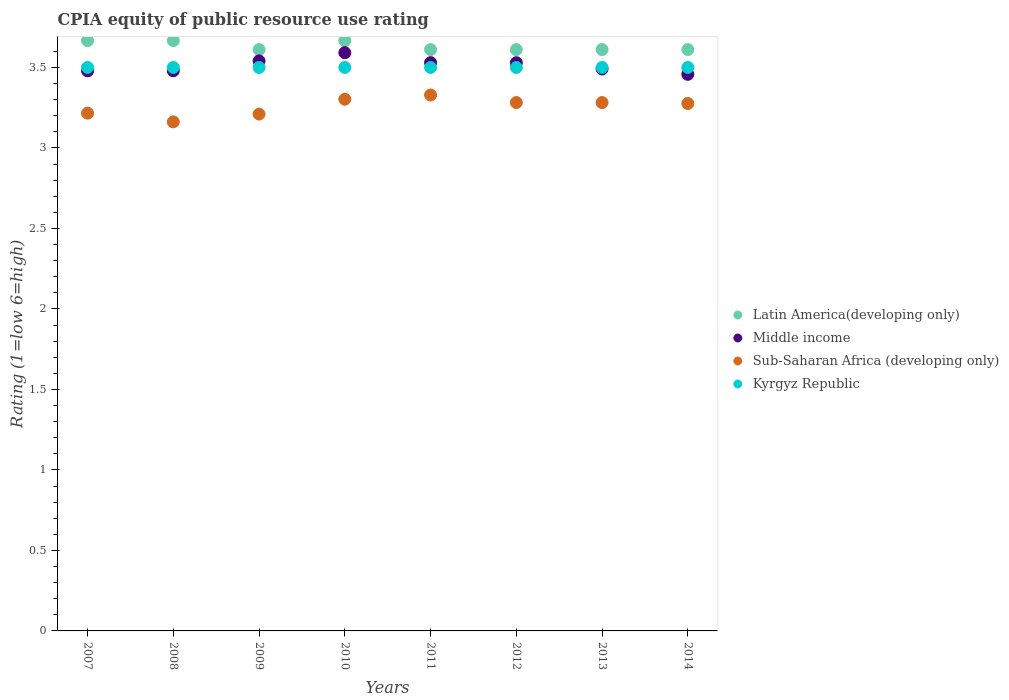What is the CPIA rating in Sub-Saharan Africa (developing only) in 2008?
Your answer should be very brief. 3.16. Across all years, what is the maximum CPIA rating in Middle income?
Give a very brief answer. 3.59. Across all years, what is the minimum CPIA rating in Kyrgyz Republic?
Your response must be concise. 3.5. What is the total CPIA rating in Kyrgyz Republic in the graph?
Ensure brevity in your answer.  28. What is the difference between the CPIA rating in Latin America(developing only) in 2013 and that in 2014?
Provide a succinct answer. 0. What is the difference between the CPIA rating in Latin America(developing only) in 2008 and the CPIA rating in Middle income in 2007?
Give a very brief answer. 0.19. What is the average CPIA rating in Kyrgyz Republic per year?
Your answer should be compact. 3.5. In the year 2009, what is the difference between the CPIA rating in Middle income and CPIA rating in Kyrgyz Republic?
Provide a succinct answer. 0.04. What is the ratio of the CPIA rating in Middle income in 2009 to that in 2012?
Give a very brief answer. 1. Is the CPIA rating in Latin America(developing only) in 2007 less than that in 2013?
Make the answer very short. No. Is the difference between the CPIA rating in Middle income in 2007 and 2008 greater than the difference between the CPIA rating in Kyrgyz Republic in 2007 and 2008?
Your response must be concise. No. What is the difference between the highest and the second highest CPIA rating in Sub-Saharan Africa (developing only)?
Offer a terse response. 0.03. Is the CPIA rating in Middle income strictly greater than the CPIA rating in Latin America(developing only) over the years?
Ensure brevity in your answer.  No. What is the difference between two consecutive major ticks on the Y-axis?
Offer a very short reply. 0.5. Does the graph contain any zero values?
Offer a very short reply. No. Does the graph contain grids?
Provide a short and direct response. No. How many legend labels are there?
Your answer should be compact. 4. How are the legend labels stacked?
Provide a succinct answer. Vertical. What is the title of the graph?
Your answer should be compact. CPIA equity of public resource use rating. What is the label or title of the X-axis?
Keep it short and to the point. Years. What is the Rating (1=low 6=high) in Latin America(developing only) in 2007?
Your answer should be compact. 3.67. What is the Rating (1=low 6=high) in Middle income in 2007?
Ensure brevity in your answer.  3.48. What is the Rating (1=low 6=high) in Sub-Saharan Africa (developing only) in 2007?
Offer a terse response. 3.22. What is the Rating (1=low 6=high) in Latin America(developing only) in 2008?
Provide a succinct answer. 3.67. What is the Rating (1=low 6=high) in Middle income in 2008?
Provide a short and direct response. 3.48. What is the Rating (1=low 6=high) of Sub-Saharan Africa (developing only) in 2008?
Provide a short and direct response. 3.16. What is the Rating (1=low 6=high) of Latin America(developing only) in 2009?
Provide a short and direct response. 3.61. What is the Rating (1=low 6=high) of Middle income in 2009?
Your answer should be compact. 3.54. What is the Rating (1=low 6=high) of Sub-Saharan Africa (developing only) in 2009?
Offer a terse response. 3.21. What is the Rating (1=low 6=high) of Latin America(developing only) in 2010?
Provide a short and direct response. 3.67. What is the Rating (1=low 6=high) in Middle income in 2010?
Make the answer very short. 3.59. What is the Rating (1=low 6=high) in Sub-Saharan Africa (developing only) in 2010?
Ensure brevity in your answer.  3.3. What is the Rating (1=low 6=high) in Kyrgyz Republic in 2010?
Your answer should be compact. 3.5. What is the Rating (1=low 6=high) in Latin America(developing only) in 2011?
Your answer should be very brief. 3.61. What is the Rating (1=low 6=high) of Middle income in 2011?
Your answer should be very brief. 3.53. What is the Rating (1=low 6=high) in Sub-Saharan Africa (developing only) in 2011?
Provide a succinct answer. 3.33. What is the Rating (1=low 6=high) in Latin America(developing only) in 2012?
Your answer should be compact. 3.61. What is the Rating (1=low 6=high) of Middle income in 2012?
Offer a terse response. 3.53. What is the Rating (1=low 6=high) of Sub-Saharan Africa (developing only) in 2012?
Make the answer very short. 3.28. What is the Rating (1=low 6=high) of Kyrgyz Republic in 2012?
Provide a short and direct response. 3.5. What is the Rating (1=low 6=high) of Latin America(developing only) in 2013?
Offer a very short reply. 3.61. What is the Rating (1=low 6=high) in Middle income in 2013?
Provide a succinct answer. 3.49. What is the Rating (1=low 6=high) of Sub-Saharan Africa (developing only) in 2013?
Ensure brevity in your answer.  3.28. What is the Rating (1=low 6=high) in Latin America(developing only) in 2014?
Ensure brevity in your answer.  3.61. What is the Rating (1=low 6=high) in Middle income in 2014?
Give a very brief answer. 3.46. What is the Rating (1=low 6=high) of Sub-Saharan Africa (developing only) in 2014?
Make the answer very short. 3.28. What is the Rating (1=low 6=high) in Kyrgyz Republic in 2014?
Offer a very short reply. 3.5. Across all years, what is the maximum Rating (1=low 6=high) in Latin America(developing only)?
Ensure brevity in your answer.  3.67. Across all years, what is the maximum Rating (1=low 6=high) of Middle income?
Keep it short and to the point. 3.59. Across all years, what is the maximum Rating (1=low 6=high) of Sub-Saharan Africa (developing only)?
Provide a short and direct response. 3.33. Across all years, what is the minimum Rating (1=low 6=high) in Latin America(developing only)?
Your response must be concise. 3.61. Across all years, what is the minimum Rating (1=low 6=high) of Middle income?
Give a very brief answer. 3.46. Across all years, what is the minimum Rating (1=low 6=high) in Sub-Saharan Africa (developing only)?
Keep it short and to the point. 3.16. Across all years, what is the minimum Rating (1=low 6=high) of Kyrgyz Republic?
Provide a succinct answer. 3.5. What is the total Rating (1=low 6=high) of Latin America(developing only) in the graph?
Keep it short and to the point. 29.06. What is the total Rating (1=low 6=high) of Middle income in the graph?
Offer a very short reply. 28.1. What is the total Rating (1=low 6=high) in Sub-Saharan Africa (developing only) in the graph?
Your response must be concise. 26.06. What is the total Rating (1=low 6=high) of Kyrgyz Republic in the graph?
Provide a succinct answer. 28. What is the difference between the Rating (1=low 6=high) of Sub-Saharan Africa (developing only) in 2007 and that in 2008?
Offer a very short reply. 0.05. What is the difference between the Rating (1=low 6=high) of Latin America(developing only) in 2007 and that in 2009?
Offer a very short reply. 0.06. What is the difference between the Rating (1=low 6=high) of Middle income in 2007 and that in 2009?
Make the answer very short. -0.06. What is the difference between the Rating (1=low 6=high) in Sub-Saharan Africa (developing only) in 2007 and that in 2009?
Offer a very short reply. 0.01. What is the difference between the Rating (1=low 6=high) in Kyrgyz Republic in 2007 and that in 2009?
Your answer should be very brief. 0. What is the difference between the Rating (1=low 6=high) of Latin America(developing only) in 2007 and that in 2010?
Your answer should be compact. 0. What is the difference between the Rating (1=low 6=high) in Middle income in 2007 and that in 2010?
Provide a short and direct response. -0.11. What is the difference between the Rating (1=low 6=high) in Sub-Saharan Africa (developing only) in 2007 and that in 2010?
Your answer should be very brief. -0.09. What is the difference between the Rating (1=low 6=high) in Kyrgyz Republic in 2007 and that in 2010?
Ensure brevity in your answer.  0. What is the difference between the Rating (1=low 6=high) in Latin America(developing only) in 2007 and that in 2011?
Make the answer very short. 0.06. What is the difference between the Rating (1=low 6=high) in Middle income in 2007 and that in 2011?
Your answer should be very brief. -0.05. What is the difference between the Rating (1=low 6=high) of Sub-Saharan Africa (developing only) in 2007 and that in 2011?
Your answer should be very brief. -0.11. What is the difference between the Rating (1=low 6=high) of Kyrgyz Republic in 2007 and that in 2011?
Provide a succinct answer. 0. What is the difference between the Rating (1=low 6=high) in Latin America(developing only) in 2007 and that in 2012?
Offer a terse response. 0.06. What is the difference between the Rating (1=low 6=high) in Middle income in 2007 and that in 2012?
Provide a succinct answer. -0.05. What is the difference between the Rating (1=low 6=high) in Sub-Saharan Africa (developing only) in 2007 and that in 2012?
Offer a terse response. -0.07. What is the difference between the Rating (1=low 6=high) in Kyrgyz Republic in 2007 and that in 2012?
Offer a very short reply. 0. What is the difference between the Rating (1=low 6=high) of Latin America(developing only) in 2007 and that in 2013?
Your answer should be compact. 0.06. What is the difference between the Rating (1=low 6=high) in Middle income in 2007 and that in 2013?
Your answer should be very brief. -0.01. What is the difference between the Rating (1=low 6=high) in Sub-Saharan Africa (developing only) in 2007 and that in 2013?
Your response must be concise. -0.07. What is the difference between the Rating (1=low 6=high) in Latin America(developing only) in 2007 and that in 2014?
Provide a short and direct response. 0.06. What is the difference between the Rating (1=low 6=high) of Middle income in 2007 and that in 2014?
Ensure brevity in your answer.  0.02. What is the difference between the Rating (1=low 6=high) in Sub-Saharan Africa (developing only) in 2007 and that in 2014?
Your answer should be compact. -0.06. What is the difference between the Rating (1=low 6=high) of Latin America(developing only) in 2008 and that in 2009?
Your answer should be compact. 0.06. What is the difference between the Rating (1=low 6=high) in Middle income in 2008 and that in 2009?
Keep it short and to the point. -0.06. What is the difference between the Rating (1=low 6=high) in Sub-Saharan Africa (developing only) in 2008 and that in 2009?
Your answer should be very brief. -0.05. What is the difference between the Rating (1=low 6=high) in Latin America(developing only) in 2008 and that in 2010?
Your response must be concise. 0. What is the difference between the Rating (1=low 6=high) in Middle income in 2008 and that in 2010?
Keep it short and to the point. -0.11. What is the difference between the Rating (1=low 6=high) of Sub-Saharan Africa (developing only) in 2008 and that in 2010?
Make the answer very short. -0.14. What is the difference between the Rating (1=low 6=high) in Kyrgyz Republic in 2008 and that in 2010?
Keep it short and to the point. 0. What is the difference between the Rating (1=low 6=high) in Latin America(developing only) in 2008 and that in 2011?
Your answer should be very brief. 0.06. What is the difference between the Rating (1=low 6=high) of Middle income in 2008 and that in 2011?
Provide a succinct answer. -0.05. What is the difference between the Rating (1=low 6=high) in Sub-Saharan Africa (developing only) in 2008 and that in 2011?
Provide a short and direct response. -0.17. What is the difference between the Rating (1=low 6=high) of Kyrgyz Republic in 2008 and that in 2011?
Your answer should be very brief. 0. What is the difference between the Rating (1=low 6=high) of Latin America(developing only) in 2008 and that in 2012?
Your answer should be very brief. 0.06. What is the difference between the Rating (1=low 6=high) in Middle income in 2008 and that in 2012?
Provide a succinct answer. -0.05. What is the difference between the Rating (1=low 6=high) in Sub-Saharan Africa (developing only) in 2008 and that in 2012?
Offer a very short reply. -0.12. What is the difference between the Rating (1=low 6=high) of Latin America(developing only) in 2008 and that in 2013?
Ensure brevity in your answer.  0.06. What is the difference between the Rating (1=low 6=high) in Middle income in 2008 and that in 2013?
Your response must be concise. -0.01. What is the difference between the Rating (1=low 6=high) in Sub-Saharan Africa (developing only) in 2008 and that in 2013?
Your response must be concise. -0.12. What is the difference between the Rating (1=low 6=high) in Kyrgyz Republic in 2008 and that in 2013?
Offer a terse response. 0. What is the difference between the Rating (1=low 6=high) of Latin America(developing only) in 2008 and that in 2014?
Your answer should be very brief. 0.06. What is the difference between the Rating (1=low 6=high) of Middle income in 2008 and that in 2014?
Offer a terse response. 0.02. What is the difference between the Rating (1=low 6=high) in Sub-Saharan Africa (developing only) in 2008 and that in 2014?
Provide a succinct answer. -0.11. What is the difference between the Rating (1=low 6=high) of Latin America(developing only) in 2009 and that in 2010?
Your response must be concise. -0.06. What is the difference between the Rating (1=low 6=high) in Middle income in 2009 and that in 2010?
Keep it short and to the point. -0.05. What is the difference between the Rating (1=low 6=high) of Sub-Saharan Africa (developing only) in 2009 and that in 2010?
Your answer should be very brief. -0.09. What is the difference between the Rating (1=low 6=high) of Kyrgyz Republic in 2009 and that in 2010?
Your answer should be compact. 0. What is the difference between the Rating (1=low 6=high) in Middle income in 2009 and that in 2011?
Your answer should be compact. 0.01. What is the difference between the Rating (1=low 6=high) of Sub-Saharan Africa (developing only) in 2009 and that in 2011?
Make the answer very short. -0.12. What is the difference between the Rating (1=low 6=high) of Latin America(developing only) in 2009 and that in 2012?
Provide a succinct answer. 0. What is the difference between the Rating (1=low 6=high) of Middle income in 2009 and that in 2012?
Your response must be concise. 0.01. What is the difference between the Rating (1=low 6=high) in Sub-Saharan Africa (developing only) in 2009 and that in 2012?
Your response must be concise. -0.07. What is the difference between the Rating (1=low 6=high) of Kyrgyz Republic in 2009 and that in 2012?
Make the answer very short. 0. What is the difference between the Rating (1=low 6=high) in Latin America(developing only) in 2009 and that in 2013?
Ensure brevity in your answer.  0. What is the difference between the Rating (1=low 6=high) of Middle income in 2009 and that in 2013?
Provide a short and direct response. 0.05. What is the difference between the Rating (1=low 6=high) in Sub-Saharan Africa (developing only) in 2009 and that in 2013?
Offer a very short reply. -0.07. What is the difference between the Rating (1=low 6=high) of Kyrgyz Republic in 2009 and that in 2013?
Keep it short and to the point. 0. What is the difference between the Rating (1=low 6=high) in Middle income in 2009 and that in 2014?
Provide a short and direct response. 0.08. What is the difference between the Rating (1=low 6=high) of Sub-Saharan Africa (developing only) in 2009 and that in 2014?
Provide a short and direct response. -0.07. What is the difference between the Rating (1=low 6=high) in Kyrgyz Republic in 2009 and that in 2014?
Offer a terse response. 0. What is the difference between the Rating (1=low 6=high) of Latin America(developing only) in 2010 and that in 2011?
Your answer should be compact. 0.06. What is the difference between the Rating (1=low 6=high) of Middle income in 2010 and that in 2011?
Your answer should be very brief. 0.06. What is the difference between the Rating (1=low 6=high) in Sub-Saharan Africa (developing only) in 2010 and that in 2011?
Provide a short and direct response. -0.03. What is the difference between the Rating (1=low 6=high) in Latin America(developing only) in 2010 and that in 2012?
Your answer should be compact. 0.06. What is the difference between the Rating (1=low 6=high) in Middle income in 2010 and that in 2012?
Provide a succinct answer. 0.06. What is the difference between the Rating (1=low 6=high) in Sub-Saharan Africa (developing only) in 2010 and that in 2012?
Your answer should be very brief. 0.02. What is the difference between the Rating (1=low 6=high) in Latin America(developing only) in 2010 and that in 2013?
Offer a very short reply. 0.06. What is the difference between the Rating (1=low 6=high) in Middle income in 2010 and that in 2013?
Make the answer very short. 0.1. What is the difference between the Rating (1=low 6=high) in Sub-Saharan Africa (developing only) in 2010 and that in 2013?
Give a very brief answer. 0.02. What is the difference between the Rating (1=low 6=high) of Latin America(developing only) in 2010 and that in 2014?
Give a very brief answer. 0.06. What is the difference between the Rating (1=low 6=high) of Middle income in 2010 and that in 2014?
Offer a terse response. 0.13. What is the difference between the Rating (1=low 6=high) of Sub-Saharan Africa (developing only) in 2010 and that in 2014?
Offer a very short reply. 0.03. What is the difference between the Rating (1=low 6=high) of Latin America(developing only) in 2011 and that in 2012?
Provide a short and direct response. 0. What is the difference between the Rating (1=low 6=high) in Middle income in 2011 and that in 2012?
Your answer should be very brief. 0. What is the difference between the Rating (1=low 6=high) of Sub-Saharan Africa (developing only) in 2011 and that in 2012?
Offer a very short reply. 0.05. What is the difference between the Rating (1=low 6=high) in Kyrgyz Republic in 2011 and that in 2012?
Provide a succinct answer. 0. What is the difference between the Rating (1=low 6=high) of Latin America(developing only) in 2011 and that in 2013?
Make the answer very short. 0. What is the difference between the Rating (1=low 6=high) of Middle income in 2011 and that in 2013?
Offer a terse response. 0.04. What is the difference between the Rating (1=low 6=high) in Sub-Saharan Africa (developing only) in 2011 and that in 2013?
Your answer should be compact. 0.05. What is the difference between the Rating (1=low 6=high) of Middle income in 2011 and that in 2014?
Keep it short and to the point. 0.07. What is the difference between the Rating (1=low 6=high) of Sub-Saharan Africa (developing only) in 2011 and that in 2014?
Your answer should be very brief. 0.05. What is the difference between the Rating (1=low 6=high) of Kyrgyz Republic in 2011 and that in 2014?
Provide a short and direct response. 0. What is the difference between the Rating (1=low 6=high) of Middle income in 2012 and that in 2013?
Keep it short and to the point. 0.04. What is the difference between the Rating (1=low 6=high) of Sub-Saharan Africa (developing only) in 2012 and that in 2013?
Offer a terse response. 0. What is the difference between the Rating (1=low 6=high) of Kyrgyz Republic in 2012 and that in 2013?
Your response must be concise. 0. What is the difference between the Rating (1=low 6=high) of Middle income in 2012 and that in 2014?
Your answer should be very brief. 0.07. What is the difference between the Rating (1=low 6=high) in Sub-Saharan Africa (developing only) in 2012 and that in 2014?
Keep it short and to the point. 0.01. What is the difference between the Rating (1=low 6=high) in Latin America(developing only) in 2013 and that in 2014?
Your answer should be compact. 0. What is the difference between the Rating (1=low 6=high) in Middle income in 2013 and that in 2014?
Provide a succinct answer. 0.03. What is the difference between the Rating (1=low 6=high) of Sub-Saharan Africa (developing only) in 2013 and that in 2014?
Your answer should be very brief. 0.01. What is the difference between the Rating (1=low 6=high) in Kyrgyz Republic in 2013 and that in 2014?
Provide a short and direct response. 0. What is the difference between the Rating (1=low 6=high) in Latin America(developing only) in 2007 and the Rating (1=low 6=high) in Middle income in 2008?
Ensure brevity in your answer.  0.19. What is the difference between the Rating (1=low 6=high) in Latin America(developing only) in 2007 and the Rating (1=low 6=high) in Sub-Saharan Africa (developing only) in 2008?
Your answer should be compact. 0.5. What is the difference between the Rating (1=low 6=high) of Latin America(developing only) in 2007 and the Rating (1=low 6=high) of Kyrgyz Republic in 2008?
Your answer should be compact. 0.17. What is the difference between the Rating (1=low 6=high) in Middle income in 2007 and the Rating (1=low 6=high) in Sub-Saharan Africa (developing only) in 2008?
Your answer should be compact. 0.32. What is the difference between the Rating (1=low 6=high) of Middle income in 2007 and the Rating (1=low 6=high) of Kyrgyz Republic in 2008?
Offer a very short reply. -0.02. What is the difference between the Rating (1=low 6=high) of Sub-Saharan Africa (developing only) in 2007 and the Rating (1=low 6=high) of Kyrgyz Republic in 2008?
Give a very brief answer. -0.28. What is the difference between the Rating (1=low 6=high) of Latin America(developing only) in 2007 and the Rating (1=low 6=high) of Middle income in 2009?
Keep it short and to the point. 0.13. What is the difference between the Rating (1=low 6=high) in Latin America(developing only) in 2007 and the Rating (1=low 6=high) in Sub-Saharan Africa (developing only) in 2009?
Give a very brief answer. 0.46. What is the difference between the Rating (1=low 6=high) in Middle income in 2007 and the Rating (1=low 6=high) in Sub-Saharan Africa (developing only) in 2009?
Your response must be concise. 0.27. What is the difference between the Rating (1=low 6=high) in Middle income in 2007 and the Rating (1=low 6=high) in Kyrgyz Republic in 2009?
Make the answer very short. -0.02. What is the difference between the Rating (1=low 6=high) in Sub-Saharan Africa (developing only) in 2007 and the Rating (1=low 6=high) in Kyrgyz Republic in 2009?
Provide a short and direct response. -0.28. What is the difference between the Rating (1=low 6=high) of Latin America(developing only) in 2007 and the Rating (1=low 6=high) of Middle income in 2010?
Make the answer very short. 0.07. What is the difference between the Rating (1=low 6=high) of Latin America(developing only) in 2007 and the Rating (1=low 6=high) of Sub-Saharan Africa (developing only) in 2010?
Your response must be concise. 0.36. What is the difference between the Rating (1=low 6=high) in Middle income in 2007 and the Rating (1=low 6=high) in Sub-Saharan Africa (developing only) in 2010?
Provide a succinct answer. 0.18. What is the difference between the Rating (1=low 6=high) of Middle income in 2007 and the Rating (1=low 6=high) of Kyrgyz Republic in 2010?
Give a very brief answer. -0.02. What is the difference between the Rating (1=low 6=high) of Sub-Saharan Africa (developing only) in 2007 and the Rating (1=low 6=high) of Kyrgyz Republic in 2010?
Keep it short and to the point. -0.28. What is the difference between the Rating (1=low 6=high) of Latin America(developing only) in 2007 and the Rating (1=low 6=high) of Middle income in 2011?
Ensure brevity in your answer.  0.14. What is the difference between the Rating (1=low 6=high) of Latin America(developing only) in 2007 and the Rating (1=low 6=high) of Sub-Saharan Africa (developing only) in 2011?
Offer a terse response. 0.34. What is the difference between the Rating (1=low 6=high) of Middle income in 2007 and the Rating (1=low 6=high) of Sub-Saharan Africa (developing only) in 2011?
Ensure brevity in your answer.  0.15. What is the difference between the Rating (1=low 6=high) of Middle income in 2007 and the Rating (1=low 6=high) of Kyrgyz Republic in 2011?
Your answer should be very brief. -0.02. What is the difference between the Rating (1=low 6=high) in Sub-Saharan Africa (developing only) in 2007 and the Rating (1=low 6=high) in Kyrgyz Republic in 2011?
Your answer should be very brief. -0.28. What is the difference between the Rating (1=low 6=high) of Latin America(developing only) in 2007 and the Rating (1=low 6=high) of Middle income in 2012?
Give a very brief answer. 0.14. What is the difference between the Rating (1=low 6=high) of Latin America(developing only) in 2007 and the Rating (1=low 6=high) of Sub-Saharan Africa (developing only) in 2012?
Your answer should be compact. 0.38. What is the difference between the Rating (1=low 6=high) in Middle income in 2007 and the Rating (1=low 6=high) in Sub-Saharan Africa (developing only) in 2012?
Give a very brief answer. 0.2. What is the difference between the Rating (1=low 6=high) in Middle income in 2007 and the Rating (1=low 6=high) in Kyrgyz Republic in 2012?
Provide a succinct answer. -0.02. What is the difference between the Rating (1=low 6=high) of Sub-Saharan Africa (developing only) in 2007 and the Rating (1=low 6=high) of Kyrgyz Republic in 2012?
Offer a very short reply. -0.28. What is the difference between the Rating (1=low 6=high) in Latin America(developing only) in 2007 and the Rating (1=low 6=high) in Middle income in 2013?
Ensure brevity in your answer.  0.18. What is the difference between the Rating (1=low 6=high) in Latin America(developing only) in 2007 and the Rating (1=low 6=high) in Sub-Saharan Africa (developing only) in 2013?
Offer a very short reply. 0.38. What is the difference between the Rating (1=low 6=high) in Latin America(developing only) in 2007 and the Rating (1=low 6=high) in Kyrgyz Republic in 2013?
Make the answer very short. 0.17. What is the difference between the Rating (1=low 6=high) of Middle income in 2007 and the Rating (1=low 6=high) of Sub-Saharan Africa (developing only) in 2013?
Give a very brief answer. 0.2. What is the difference between the Rating (1=low 6=high) of Middle income in 2007 and the Rating (1=low 6=high) of Kyrgyz Republic in 2013?
Your answer should be compact. -0.02. What is the difference between the Rating (1=low 6=high) of Sub-Saharan Africa (developing only) in 2007 and the Rating (1=low 6=high) of Kyrgyz Republic in 2013?
Give a very brief answer. -0.28. What is the difference between the Rating (1=low 6=high) of Latin America(developing only) in 2007 and the Rating (1=low 6=high) of Middle income in 2014?
Your response must be concise. 0.21. What is the difference between the Rating (1=low 6=high) of Latin America(developing only) in 2007 and the Rating (1=low 6=high) of Sub-Saharan Africa (developing only) in 2014?
Make the answer very short. 0.39. What is the difference between the Rating (1=low 6=high) in Latin America(developing only) in 2007 and the Rating (1=low 6=high) in Kyrgyz Republic in 2014?
Offer a very short reply. 0.17. What is the difference between the Rating (1=low 6=high) of Middle income in 2007 and the Rating (1=low 6=high) of Sub-Saharan Africa (developing only) in 2014?
Offer a terse response. 0.2. What is the difference between the Rating (1=low 6=high) in Middle income in 2007 and the Rating (1=low 6=high) in Kyrgyz Republic in 2014?
Provide a succinct answer. -0.02. What is the difference between the Rating (1=low 6=high) in Sub-Saharan Africa (developing only) in 2007 and the Rating (1=low 6=high) in Kyrgyz Republic in 2014?
Your response must be concise. -0.28. What is the difference between the Rating (1=low 6=high) in Latin America(developing only) in 2008 and the Rating (1=low 6=high) in Middle income in 2009?
Ensure brevity in your answer.  0.13. What is the difference between the Rating (1=low 6=high) in Latin America(developing only) in 2008 and the Rating (1=low 6=high) in Sub-Saharan Africa (developing only) in 2009?
Ensure brevity in your answer.  0.46. What is the difference between the Rating (1=low 6=high) in Latin America(developing only) in 2008 and the Rating (1=low 6=high) in Kyrgyz Republic in 2009?
Make the answer very short. 0.17. What is the difference between the Rating (1=low 6=high) of Middle income in 2008 and the Rating (1=low 6=high) of Sub-Saharan Africa (developing only) in 2009?
Ensure brevity in your answer.  0.27. What is the difference between the Rating (1=low 6=high) in Middle income in 2008 and the Rating (1=low 6=high) in Kyrgyz Republic in 2009?
Your answer should be very brief. -0.02. What is the difference between the Rating (1=low 6=high) of Sub-Saharan Africa (developing only) in 2008 and the Rating (1=low 6=high) of Kyrgyz Republic in 2009?
Your answer should be very brief. -0.34. What is the difference between the Rating (1=low 6=high) in Latin America(developing only) in 2008 and the Rating (1=low 6=high) in Middle income in 2010?
Provide a succinct answer. 0.07. What is the difference between the Rating (1=low 6=high) of Latin America(developing only) in 2008 and the Rating (1=low 6=high) of Sub-Saharan Africa (developing only) in 2010?
Ensure brevity in your answer.  0.36. What is the difference between the Rating (1=low 6=high) in Middle income in 2008 and the Rating (1=low 6=high) in Sub-Saharan Africa (developing only) in 2010?
Give a very brief answer. 0.18. What is the difference between the Rating (1=low 6=high) in Middle income in 2008 and the Rating (1=low 6=high) in Kyrgyz Republic in 2010?
Provide a short and direct response. -0.02. What is the difference between the Rating (1=low 6=high) of Sub-Saharan Africa (developing only) in 2008 and the Rating (1=low 6=high) of Kyrgyz Republic in 2010?
Give a very brief answer. -0.34. What is the difference between the Rating (1=low 6=high) of Latin America(developing only) in 2008 and the Rating (1=low 6=high) of Middle income in 2011?
Your answer should be very brief. 0.14. What is the difference between the Rating (1=low 6=high) of Latin America(developing only) in 2008 and the Rating (1=low 6=high) of Sub-Saharan Africa (developing only) in 2011?
Provide a short and direct response. 0.34. What is the difference between the Rating (1=low 6=high) in Middle income in 2008 and the Rating (1=low 6=high) in Sub-Saharan Africa (developing only) in 2011?
Your answer should be compact. 0.15. What is the difference between the Rating (1=low 6=high) in Middle income in 2008 and the Rating (1=low 6=high) in Kyrgyz Republic in 2011?
Your answer should be very brief. -0.02. What is the difference between the Rating (1=low 6=high) of Sub-Saharan Africa (developing only) in 2008 and the Rating (1=low 6=high) of Kyrgyz Republic in 2011?
Keep it short and to the point. -0.34. What is the difference between the Rating (1=low 6=high) in Latin America(developing only) in 2008 and the Rating (1=low 6=high) in Middle income in 2012?
Offer a very short reply. 0.14. What is the difference between the Rating (1=low 6=high) in Latin America(developing only) in 2008 and the Rating (1=low 6=high) in Sub-Saharan Africa (developing only) in 2012?
Your response must be concise. 0.38. What is the difference between the Rating (1=low 6=high) in Middle income in 2008 and the Rating (1=low 6=high) in Sub-Saharan Africa (developing only) in 2012?
Your answer should be compact. 0.2. What is the difference between the Rating (1=low 6=high) in Middle income in 2008 and the Rating (1=low 6=high) in Kyrgyz Republic in 2012?
Give a very brief answer. -0.02. What is the difference between the Rating (1=low 6=high) of Sub-Saharan Africa (developing only) in 2008 and the Rating (1=low 6=high) of Kyrgyz Republic in 2012?
Provide a succinct answer. -0.34. What is the difference between the Rating (1=low 6=high) in Latin America(developing only) in 2008 and the Rating (1=low 6=high) in Middle income in 2013?
Offer a very short reply. 0.18. What is the difference between the Rating (1=low 6=high) of Latin America(developing only) in 2008 and the Rating (1=low 6=high) of Sub-Saharan Africa (developing only) in 2013?
Your answer should be compact. 0.38. What is the difference between the Rating (1=low 6=high) in Middle income in 2008 and the Rating (1=low 6=high) in Sub-Saharan Africa (developing only) in 2013?
Your response must be concise. 0.2. What is the difference between the Rating (1=low 6=high) of Middle income in 2008 and the Rating (1=low 6=high) of Kyrgyz Republic in 2013?
Your response must be concise. -0.02. What is the difference between the Rating (1=low 6=high) of Sub-Saharan Africa (developing only) in 2008 and the Rating (1=low 6=high) of Kyrgyz Republic in 2013?
Provide a succinct answer. -0.34. What is the difference between the Rating (1=low 6=high) of Latin America(developing only) in 2008 and the Rating (1=low 6=high) of Middle income in 2014?
Provide a short and direct response. 0.21. What is the difference between the Rating (1=low 6=high) of Latin America(developing only) in 2008 and the Rating (1=low 6=high) of Sub-Saharan Africa (developing only) in 2014?
Your response must be concise. 0.39. What is the difference between the Rating (1=low 6=high) in Latin America(developing only) in 2008 and the Rating (1=low 6=high) in Kyrgyz Republic in 2014?
Provide a succinct answer. 0.17. What is the difference between the Rating (1=low 6=high) in Middle income in 2008 and the Rating (1=low 6=high) in Sub-Saharan Africa (developing only) in 2014?
Make the answer very short. 0.2. What is the difference between the Rating (1=low 6=high) in Middle income in 2008 and the Rating (1=low 6=high) in Kyrgyz Republic in 2014?
Ensure brevity in your answer.  -0.02. What is the difference between the Rating (1=low 6=high) of Sub-Saharan Africa (developing only) in 2008 and the Rating (1=low 6=high) of Kyrgyz Republic in 2014?
Give a very brief answer. -0.34. What is the difference between the Rating (1=low 6=high) of Latin America(developing only) in 2009 and the Rating (1=low 6=high) of Middle income in 2010?
Provide a short and direct response. 0.02. What is the difference between the Rating (1=low 6=high) in Latin America(developing only) in 2009 and the Rating (1=low 6=high) in Sub-Saharan Africa (developing only) in 2010?
Ensure brevity in your answer.  0.31. What is the difference between the Rating (1=low 6=high) in Latin America(developing only) in 2009 and the Rating (1=low 6=high) in Kyrgyz Republic in 2010?
Offer a very short reply. 0.11. What is the difference between the Rating (1=low 6=high) in Middle income in 2009 and the Rating (1=low 6=high) in Sub-Saharan Africa (developing only) in 2010?
Offer a terse response. 0.24. What is the difference between the Rating (1=low 6=high) in Middle income in 2009 and the Rating (1=low 6=high) in Kyrgyz Republic in 2010?
Your response must be concise. 0.04. What is the difference between the Rating (1=low 6=high) in Sub-Saharan Africa (developing only) in 2009 and the Rating (1=low 6=high) in Kyrgyz Republic in 2010?
Your response must be concise. -0.29. What is the difference between the Rating (1=low 6=high) of Latin America(developing only) in 2009 and the Rating (1=low 6=high) of Middle income in 2011?
Provide a succinct answer. 0.08. What is the difference between the Rating (1=low 6=high) in Latin America(developing only) in 2009 and the Rating (1=low 6=high) in Sub-Saharan Africa (developing only) in 2011?
Offer a terse response. 0.28. What is the difference between the Rating (1=low 6=high) in Latin America(developing only) in 2009 and the Rating (1=low 6=high) in Kyrgyz Republic in 2011?
Make the answer very short. 0.11. What is the difference between the Rating (1=low 6=high) in Middle income in 2009 and the Rating (1=low 6=high) in Sub-Saharan Africa (developing only) in 2011?
Your answer should be very brief. 0.21. What is the difference between the Rating (1=low 6=high) in Middle income in 2009 and the Rating (1=low 6=high) in Kyrgyz Republic in 2011?
Offer a terse response. 0.04. What is the difference between the Rating (1=low 6=high) in Sub-Saharan Africa (developing only) in 2009 and the Rating (1=low 6=high) in Kyrgyz Republic in 2011?
Keep it short and to the point. -0.29. What is the difference between the Rating (1=low 6=high) of Latin America(developing only) in 2009 and the Rating (1=low 6=high) of Middle income in 2012?
Provide a short and direct response. 0.08. What is the difference between the Rating (1=low 6=high) in Latin America(developing only) in 2009 and the Rating (1=low 6=high) in Sub-Saharan Africa (developing only) in 2012?
Your response must be concise. 0.33. What is the difference between the Rating (1=low 6=high) in Middle income in 2009 and the Rating (1=low 6=high) in Sub-Saharan Africa (developing only) in 2012?
Offer a terse response. 0.26. What is the difference between the Rating (1=low 6=high) of Middle income in 2009 and the Rating (1=low 6=high) of Kyrgyz Republic in 2012?
Provide a short and direct response. 0.04. What is the difference between the Rating (1=low 6=high) of Sub-Saharan Africa (developing only) in 2009 and the Rating (1=low 6=high) of Kyrgyz Republic in 2012?
Your answer should be very brief. -0.29. What is the difference between the Rating (1=low 6=high) in Latin America(developing only) in 2009 and the Rating (1=low 6=high) in Middle income in 2013?
Your response must be concise. 0.12. What is the difference between the Rating (1=low 6=high) in Latin America(developing only) in 2009 and the Rating (1=low 6=high) in Sub-Saharan Africa (developing only) in 2013?
Offer a terse response. 0.33. What is the difference between the Rating (1=low 6=high) in Middle income in 2009 and the Rating (1=low 6=high) in Sub-Saharan Africa (developing only) in 2013?
Keep it short and to the point. 0.26. What is the difference between the Rating (1=low 6=high) in Middle income in 2009 and the Rating (1=low 6=high) in Kyrgyz Republic in 2013?
Provide a short and direct response. 0.04. What is the difference between the Rating (1=low 6=high) of Sub-Saharan Africa (developing only) in 2009 and the Rating (1=low 6=high) of Kyrgyz Republic in 2013?
Offer a very short reply. -0.29. What is the difference between the Rating (1=low 6=high) of Latin America(developing only) in 2009 and the Rating (1=low 6=high) of Middle income in 2014?
Offer a very short reply. 0.15. What is the difference between the Rating (1=low 6=high) in Latin America(developing only) in 2009 and the Rating (1=low 6=high) in Sub-Saharan Africa (developing only) in 2014?
Your answer should be very brief. 0.33. What is the difference between the Rating (1=low 6=high) of Middle income in 2009 and the Rating (1=low 6=high) of Sub-Saharan Africa (developing only) in 2014?
Provide a succinct answer. 0.26. What is the difference between the Rating (1=low 6=high) of Middle income in 2009 and the Rating (1=low 6=high) of Kyrgyz Republic in 2014?
Provide a short and direct response. 0.04. What is the difference between the Rating (1=low 6=high) of Sub-Saharan Africa (developing only) in 2009 and the Rating (1=low 6=high) of Kyrgyz Republic in 2014?
Ensure brevity in your answer.  -0.29. What is the difference between the Rating (1=low 6=high) of Latin America(developing only) in 2010 and the Rating (1=low 6=high) of Middle income in 2011?
Offer a terse response. 0.14. What is the difference between the Rating (1=low 6=high) in Latin America(developing only) in 2010 and the Rating (1=low 6=high) in Sub-Saharan Africa (developing only) in 2011?
Provide a succinct answer. 0.34. What is the difference between the Rating (1=low 6=high) in Latin America(developing only) in 2010 and the Rating (1=low 6=high) in Kyrgyz Republic in 2011?
Keep it short and to the point. 0.17. What is the difference between the Rating (1=low 6=high) in Middle income in 2010 and the Rating (1=low 6=high) in Sub-Saharan Africa (developing only) in 2011?
Your answer should be very brief. 0.26. What is the difference between the Rating (1=low 6=high) of Middle income in 2010 and the Rating (1=low 6=high) of Kyrgyz Republic in 2011?
Your response must be concise. 0.09. What is the difference between the Rating (1=low 6=high) in Sub-Saharan Africa (developing only) in 2010 and the Rating (1=low 6=high) in Kyrgyz Republic in 2011?
Provide a short and direct response. -0.2. What is the difference between the Rating (1=low 6=high) of Latin America(developing only) in 2010 and the Rating (1=low 6=high) of Middle income in 2012?
Give a very brief answer. 0.14. What is the difference between the Rating (1=low 6=high) of Latin America(developing only) in 2010 and the Rating (1=low 6=high) of Sub-Saharan Africa (developing only) in 2012?
Offer a very short reply. 0.38. What is the difference between the Rating (1=low 6=high) in Latin America(developing only) in 2010 and the Rating (1=low 6=high) in Kyrgyz Republic in 2012?
Your response must be concise. 0.17. What is the difference between the Rating (1=low 6=high) in Middle income in 2010 and the Rating (1=low 6=high) in Sub-Saharan Africa (developing only) in 2012?
Give a very brief answer. 0.31. What is the difference between the Rating (1=low 6=high) in Middle income in 2010 and the Rating (1=low 6=high) in Kyrgyz Republic in 2012?
Offer a very short reply. 0.09. What is the difference between the Rating (1=low 6=high) of Sub-Saharan Africa (developing only) in 2010 and the Rating (1=low 6=high) of Kyrgyz Republic in 2012?
Your response must be concise. -0.2. What is the difference between the Rating (1=low 6=high) in Latin America(developing only) in 2010 and the Rating (1=low 6=high) in Middle income in 2013?
Provide a succinct answer. 0.18. What is the difference between the Rating (1=low 6=high) in Latin America(developing only) in 2010 and the Rating (1=low 6=high) in Sub-Saharan Africa (developing only) in 2013?
Ensure brevity in your answer.  0.38. What is the difference between the Rating (1=low 6=high) of Middle income in 2010 and the Rating (1=low 6=high) of Sub-Saharan Africa (developing only) in 2013?
Offer a very short reply. 0.31. What is the difference between the Rating (1=low 6=high) of Middle income in 2010 and the Rating (1=low 6=high) of Kyrgyz Republic in 2013?
Ensure brevity in your answer.  0.09. What is the difference between the Rating (1=low 6=high) in Sub-Saharan Africa (developing only) in 2010 and the Rating (1=low 6=high) in Kyrgyz Republic in 2013?
Provide a succinct answer. -0.2. What is the difference between the Rating (1=low 6=high) of Latin America(developing only) in 2010 and the Rating (1=low 6=high) of Middle income in 2014?
Give a very brief answer. 0.21. What is the difference between the Rating (1=low 6=high) in Latin America(developing only) in 2010 and the Rating (1=low 6=high) in Sub-Saharan Africa (developing only) in 2014?
Give a very brief answer. 0.39. What is the difference between the Rating (1=low 6=high) in Latin America(developing only) in 2010 and the Rating (1=low 6=high) in Kyrgyz Republic in 2014?
Your response must be concise. 0.17. What is the difference between the Rating (1=low 6=high) in Middle income in 2010 and the Rating (1=low 6=high) in Sub-Saharan Africa (developing only) in 2014?
Make the answer very short. 0.32. What is the difference between the Rating (1=low 6=high) of Middle income in 2010 and the Rating (1=low 6=high) of Kyrgyz Republic in 2014?
Your response must be concise. 0.09. What is the difference between the Rating (1=low 6=high) in Sub-Saharan Africa (developing only) in 2010 and the Rating (1=low 6=high) in Kyrgyz Republic in 2014?
Your answer should be very brief. -0.2. What is the difference between the Rating (1=low 6=high) of Latin America(developing only) in 2011 and the Rating (1=low 6=high) of Middle income in 2012?
Ensure brevity in your answer.  0.08. What is the difference between the Rating (1=low 6=high) in Latin America(developing only) in 2011 and the Rating (1=low 6=high) in Sub-Saharan Africa (developing only) in 2012?
Your answer should be compact. 0.33. What is the difference between the Rating (1=low 6=high) in Latin America(developing only) in 2011 and the Rating (1=low 6=high) in Kyrgyz Republic in 2012?
Your answer should be compact. 0.11. What is the difference between the Rating (1=low 6=high) of Middle income in 2011 and the Rating (1=low 6=high) of Sub-Saharan Africa (developing only) in 2012?
Keep it short and to the point. 0.25. What is the difference between the Rating (1=low 6=high) of Sub-Saharan Africa (developing only) in 2011 and the Rating (1=low 6=high) of Kyrgyz Republic in 2012?
Your answer should be compact. -0.17. What is the difference between the Rating (1=low 6=high) in Latin America(developing only) in 2011 and the Rating (1=low 6=high) in Middle income in 2013?
Ensure brevity in your answer.  0.12. What is the difference between the Rating (1=low 6=high) of Latin America(developing only) in 2011 and the Rating (1=low 6=high) of Sub-Saharan Africa (developing only) in 2013?
Make the answer very short. 0.33. What is the difference between the Rating (1=low 6=high) of Middle income in 2011 and the Rating (1=low 6=high) of Sub-Saharan Africa (developing only) in 2013?
Keep it short and to the point. 0.25. What is the difference between the Rating (1=low 6=high) in Middle income in 2011 and the Rating (1=low 6=high) in Kyrgyz Republic in 2013?
Provide a succinct answer. 0.03. What is the difference between the Rating (1=low 6=high) of Sub-Saharan Africa (developing only) in 2011 and the Rating (1=low 6=high) of Kyrgyz Republic in 2013?
Your response must be concise. -0.17. What is the difference between the Rating (1=low 6=high) of Latin America(developing only) in 2011 and the Rating (1=low 6=high) of Middle income in 2014?
Provide a succinct answer. 0.15. What is the difference between the Rating (1=low 6=high) in Latin America(developing only) in 2011 and the Rating (1=low 6=high) in Sub-Saharan Africa (developing only) in 2014?
Your answer should be very brief. 0.33. What is the difference between the Rating (1=low 6=high) of Middle income in 2011 and the Rating (1=low 6=high) of Sub-Saharan Africa (developing only) in 2014?
Your answer should be very brief. 0.25. What is the difference between the Rating (1=low 6=high) of Middle income in 2011 and the Rating (1=low 6=high) of Kyrgyz Republic in 2014?
Offer a very short reply. 0.03. What is the difference between the Rating (1=low 6=high) of Sub-Saharan Africa (developing only) in 2011 and the Rating (1=low 6=high) of Kyrgyz Republic in 2014?
Your answer should be very brief. -0.17. What is the difference between the Rating (1=low 6=high) of Latin America(developing only) in 2012 and the Rating (1=low 6=high) of Middle income in 2013?
Provide a succinct answer. 0.12. What is the difference between the Rating (1=low 6=high) in Latin America(developing only) in 2012 and the Rating (1=low 6=high) in Sub-Saharan Africa (developing only) in 2013?
Your answer should be compact. 0.33. What is the difference between the Rating (1=low 6=high) of Latin America(developing only) in 2012 and the Rating (1=low 6=high) of Kyrgyz Republic in 2013?
Provide a short and direct response. 0.11. What is the difference between the Rating (1=low 6=high) of Middle income in 2012 and the Rating (1=low 6=high) of Sub-Saharan Africa (developing only) in 2013?
Your answer should be compact. 0.25. What is the difference between the Rating (1=low 6=high) of Middle income in 2012 and the Rating (1=low 6=high) of Kyrgyz Republic in 2013?
Your answer should be compact. 0.03. What is the difference between the Rating (1=low 6=high) in Sub-Saharan Africa (developing only) in 2012 and the Rating (1=low 6=high) in Kyrgyz Republic in 2013?
Offer a terse response. -0.22. What is the difference between the Rating (1=low 6=high) of Latin America(developing only) in 2012 and the Rating (1=low 6=high) of Middle income in 2014?
Offer a very short reply. 0.15. What is the difference between the Rating (1=low 6=high) of Latin America(developing only) in 2012 and the Rating (1=low 6=high) of Sub-Saharan Africa (developing only) in 2014?
Give a very brief answer. 0.33. What is the difference between the Rating (1=low 6=high) of Latin America(developing only) in 2012 and the Rating (1=low 6=high) of Kyrgyz Republic in 2014?
Give a very brief answer. 0.11. What is the difference between the Rating (1=low 6=high) in Middle income in 2012 and the Rating (1=low 6=high) in Sub-Saharan Africa (developing only) in 2014?
Your answer should be very brief. 0.25. What is the difference between the Rating (1=low 6=high) of Middle income in 2012 and the Rating (1=low 6=high) of Kyrgyz Republic in 2014?
Make the answer very short. 0.03. What is the difference between the Rating (1=low 6=high) of Sub-Saharan Africa (developing only) in 2012 and the Rating (1=low 6=high) of Kyrgyz Republic in 2014?
Provide a short and direct response. -0.22. What is the difference between the Rating (1=low 6=high) in Latin America(developing only) in 2013 and the Rating (1=low 6=high) in Middle income in 2014?
Your answer should be very brief. 0.15. What is the difference between the Rating (1=low 6=high) in Latin America(developing only) in 2013 and the Rating (1=low 6=high) in Sub-Saharan Africa (developing only) in 2014?
Ensure brevity in your answer.  0.33. What is the difference between the Rating (1=low 6=high) in Latin America(developing only) in 2013 and the Rating (1=low 6=high) in Kyrgyz Republic in 2014?
Keep it short and to the point. 0.11. What is the difference between the Rating (1=low 6=high) of Middle income in 2013 and the Rating (1=low 6=high) of Sub-Saharan Africa (developing only) in 2014?
Keep it short and to the point. 0.21. What is the difference between the Rating (1=low 6=high) in Middle income in 2013 and the Rating (1=low 6=high) in Kyrgyz Republic in 2014?
Ensure brevity in your answer.  -0.01. What is the difference between the Rating (1=low 6=high) in Sub-Saharan Africa (developing only) in 2013 and the Rating (1=low 6=high) in Kyrgyz Republic in 2014?
Make the answer very short. -0.22. What is the average Rating (1=low 6=high) in Latin America(developing only) per year?
Offer a very short reply. 3.63. What is the average Rating (1=low 6=high) of Middle income per year?
Give a very brief answer. 3.51. What is the average Rating (1=low 6=high) in Sub-Saharan Africa (developing only) per year?
Offer a very short reply. 3.26. What is the average Rating (1=low 6=high) in Kyrgyz Republic per year?
Your answer should be compact. 3.5. In the year 2007, what is the difference between the Rating (1=low 6=high) in Latin America(developing only) and Rating (1=low 6=high) in Middle income?
Ensure brevity in your answer.  0.19. In the year 2007, what is the difference between the Rating (1=low 6=high) of Latin America(developing only) and Rating (1=low 6=high) of Sub-Saharan Africa (developing only)?
Make the answer very short. 0.45. In the year 2007, what is the difference between the Rating (1=low 6=high) in Middle income and Rating (1=low 6=high) in Sub-Saharan Africa (developing only)?
Ensure brevity in your answer.  0.26. In the year 2007, what is the difference between the Rating (1=low 6=high) in Middle income and Rating (1=low 6=high) in Kyrgyz Republic?
Keep it short and to the point. -0.02. In the year 2007, what is the difference between the Rating (1=low 6=high) in Sub-Saharan Africa (developing only) and Rating (1=low 6=high) in Kyrgyz Republic?
Your answer should be compact. -0.28. In the year 2008, what is the difference between the Rating (1=low 6=high) in Latin America(developing only) and Rating (1=low 6=high) in Middle income?
Ensure brevity in your answer.  0.19. In the year 2008, what is the difference between the Rating (1=low 6=high) in Latin America(developing only) and Rating (1=low 6=high) in Sub-Saharan Africa (developing only)?
Give a very brief answer. 0.5. In the year 2008, what is the difference between the Rating (1=low 6=high) of Middle income and Rating (1=low 6=high) of Sub-Saharan Africa (developing only)?
Provide a succinct answer. 0.32. In the year 2008, what is the difference between the Rating (1=low 6=high) of Middle income and Rating (1=low 6=high) of Kyrgyz Republic?
Your answer should be very brief. -0.02. In the year 2008, what is the difference between the Rating (1=low 6=high) of Sub-Saharan Africa (developing only) and Rating (1=low 6=high) of Kyrgyz Republic?
Make the answer very short. -0.34. In the year 2009, what is the difference between the Rating (1=low 6=high) in Latin America(developing only) and Rating (1=low 6=high) in Middle income?
Give a very brief answer. 0.07. In the year 2009, what is the difference between the Rating (1=low 6=high) in Latin America(developing only) and Rating (1=low 6=high) in Sub-Saharan Africa (developing only)?
Keep it short and to the point. 0.4. In the year 2009, what is the difference between the Rating (1=low 6=high) in Latin America(developing only) and Rating (1=low 6=high) in Kyrgyz Republic?
Provide a short and direct response. 0.11. In the year 2009, what is the difference between the Rating (1=low 6=high) in Middle income and Rating (1=low 6=high) in Sub-Saharan Africa (developing only)?
Your response must be concise. 0.33. In the year 2009, what is the difference between the Rating (1=low 6=high) in Middle income and Rating (1=low 6=high) in Kyrgyz Republic?
Your answer should be very brief. 0.04. In the year 2009, what is the difference between the Rating (1=low 6=high) in Sub-Saharan Africa (developing only) and Rating (1=low 6=high) in Kyrgyz Republic?
Give a very brief answer. -0.29. In the year 2010, what is the difference between the Rating (1=low 6=high) in Latin America(developing only) and Rating (1=low 6=high) in Middle income?
Provide a short and direct response. 0.07. In the year 2010, what is the difference between the Rating (1=low 6=high) of Latin America(developing only) and Rating (1=low 6=high) of Sub-Saharan Africa (developing only)?
Keep it short and to the point. 0.36. In the year 2010, what is the difference between the Rating (1=low 6=high) of Latin America(developing only) and Rating (1=low 6=high) of Kyrgyz Republic?
Your response must be concise. 0.17. In the year 2010, what is the difference between the Rating (1=low 6=high) in Middle income and Rating (1=low 6=high) in Sub-Saharan Africa (developing only)?
Your answer should be compact. 0.29. In the year 2010, what is the difference between the Rating (1=low 6=high) of Middle income and Rating (1=low 6=high) of Kyrgyz Republic?
Offer a terse response. 0.09. In the year 2010, what is the difference between the Rating (1=low 6=high) in Sub-Saharan Africa (developing only) and Rating (1=low 6=high) in Kyrgyz Republic?
Your answer should be very brief. -0.2. In the year 2011, what is the difference between the Rating (1=low 6=high) of Latin America(developing only) and Rating (1=low 6=high) of Middle income?
Make the answer very short. 0.08. In the year 2011, what is the difference between the Rating (1=low 6=high) in Latin America(developing only) and Rating (1=low 6=high) in Sub-Saharan Africa (developing only)?
Your answer should be very brief. 0.28. In the year 2011, what is the difference between the Rating (1=low 6=high) in Latin America(developing only) and Rating (1=low 6=high) in Kyrgyz Republic?
Your response must be concise. 0.11. In the year 2011, what is the difference between the Rating (1=low 6=high) in Middle income and Rating (1=low 6=high) in Sub-Saharan Africa (developing only)?
Your answer should be very brief. 0.2. In the year 2011, what is the difference between the Rating (1=low 6=high) in Middle income and Rating (1=low 6=high) in Kyrgyz Republic?
Your response must be concise. 0.03. In the year 2011, what is the difference between the Rating (1=low 6=high) in Sub-Saharan Africa (developing only) and Rating (1=low 6=high) in Kyrgyz Republic?
Your answer should be compact. -0.17. In the year 2012, what is the difference between the Rating (1=low 6=high) in Latin America(developing only) and Rating (1=low 6=high) in Middle income?
Provide a short and direct response. 0.08. In the year 2012, what is the difference between the Rating (1=low 6=high) in Latin America(developing only) and Rating (1=low 6=high) in Sub-Saharan Africa (developing only)?
Your answer should be compact. 0.33. In the year 2012, what is the difference between the Rating (1=low 6=high) in Middle income and Rating (1=low 6=high) in Sub-Saharan Africa (developing only)?
Your answer should be compact. 0.25. In the year 2012, what is the difference between the Rating (1=low 6=high) of Middle income and Rating (1=low 6=high) of Kyrgyz Republic?
Provide a succinct answer. 0.03. In the year 2012, what is the difference between the Rating (1=low 6=high) of Sub-Saharan Africa (developing only) and Rating (1=low 6=high) of Kyrgyz Republic?
Keep it short and to the point. -0.22. In the year 2013, what is the difference between the Rating (1=low 6=high) of Latin America(developing only) and Rating (1=low 6=high) of Middle income?
Offer a very short reply. 0.12. In the year 2013, what is the difference between the Rating (1=low 6=high) in Latin America(developing only) and Rating (1=low 6=high) in Sub-Saharan Africa (developing only)?
Give a very brief answer. 0.33. In the year 2013, what is the difference between the Rating (1=low 6=high) of Latin America(developing only) and Rating (1=low 6=high) of Kyrgyz Republic?
Ensure brevity in your answer.  0.11. In the year 2013, what is the difference between the Rating (1=low 6=high) of Middle income and Rating (1=low 6=high) of Sub-Saharan Africa (developing only)?
Offer a very short reply. 0.21. In the year 2013, what is the difference between the Rating (1=low 6=high) in Middle income and Rating (1=low 6=high) in Kyrgyz Republic?
Provide a short and direct response. -0.01. In the year 2013, what is the difference between the Rating (1=low 6=high) of Sub-Saharan Africa (developing only) and Rating (1=low 6=high) of Kyrgyz Republic?
Provide a succinct answer. -0.22. In the year 2014, what is the difference between the Rating (1=low 6=high) in Latin America(developing only) and Rating (1=low 6=high) in Middle income?
Give a very brief answer. 0.15. In the year 2014, what is the difference between the Rating (1=low 6=high) in Latin America(developing only) and Rating (1=low 6=high) in Sub-Saharan Africa (developing only)?
Provide a succinct answer. 0.33. In the year 2014, what is the difference between the Rating (1=low 6=high) of Latin America(developing only) and Rating (1=low 6=high) of Kyrgyz Republic?
Ensure brevity in your answer.  0.11. In the year 2014, what is the difference between the Rating (1=low 6=high) in Middle income and Rating (1=low 6=high) in Sub-Saharan Africa (developing only)?
Give a very brief answer. 0.18. In the year 2014, what is the difference between the Rating (1=low 6=high) of Middle income and Rating (1=low 6=high) of Kyrgyz Republic?
Your answer should be compact. -0.04. In the year 2014, what is the difference between the Rating (1=low 6=high) of Sub-Saharan Africa (developing only) and Rating (1=low 6=high) of Kyrgyz Republic?
Your answer should be compact. -0.22. What is the ratio of the Rating (1=low 6=high) in Latin America(developing only) in 2007 to that in 2008?
Your answer should be compact. 1. What is the ratio of the Rating (1=low 6=high) in Sub-Saharan Africa (developing only) in 2007 to that in 2008?
Offer a terse response. 1.02. What is the ratio of the Rating (1=low 6=high) of Kyrgyz Republic in 2007 to that in 2008?
Provide a short and direct response. 1. What is the ratio of the Rating (1=low 6=high) in Latin America(developing only) in 2007 to that in 2009?
Your answer should be very brief. 1.02. What is the ratio of the Rating (1=low 6=high) in Middle income in 2007 to that in 2009?
Make the answer very short. 0.98. What is the ratio of the Rating (1=low 6=high) of Latin America(developing only) in 2007 to that in 2010?
Keep it short and to the point. 1. What is the ratio of the Rating (1=low 6=high) in Middle income in 2007 to that in 2010?
Provide a short and direct response. 0.97. What is the ratio of the Rating (1=low 6=high) in Sub-Saharan Africa (developing only) in 2007 to that in 2010?
Your answer should be compact. 0.97. What is the ratio of the Rating (1=low 6=high) in Latin America(developing only) in 2007 to that in 2011?
Provide a short and direct response. 1.02. What is the ratio of the Rating (1=low 6=high) of Middle income in 2007 to that in 2011?
Offer a very short reply. 0.99. What is the ratio of the Rating (1=low 6=high) of Sub-Saharan Africa (developing only) in 2007 to that in 2011?
Your response must be concise. 0.97. What is the ratio of the Rating (1=low 6=high) in Latin America(developing only) in 2007 to that in 2012?
Your answer should be compact. 1.02. What is the ratio of the Rating (1=low 6=high) in Middle income in 2007 to that in 2012?
Offer a very short reply. 0.99. What is the ratio of the Rating (1=low 6=high) in Sub-Saharan Africa (developing only) in 2007 to that in 2012?
Offer a very short reply. 0.98. What is the ratio of the Rating (1=low 6=high) of Kyrgyz Republic in 2007 to that in 2012?
Give a very brief answer. 1. What is the ratio of the Rating (1=low 6=high) in Latin America(developing only) in 2007 to that in 2013?
Make the answer very short. 1.02. What is the ratio of the Rating (1=low 6=high) of Sub-Saharan Africa (developing only) in 2007 to that in 2013?
Your answer should be compact. 0.98. What is the ratio of the Rating (1=low 6=high) of Latin America(developing only) in 2007 to that in 2014?
Give a very brief answer. 1.02. What is the ratio of the Rating (1=low 6=high) in Middle income in 2007 to that in 2014?
Your response must be concise. 1.01. What is the ratio of the Rating (1=low 6=high) in Sub-Saharan Africa (developing only) in 2007 to that in 2014?
Give a very brief answer. 0.98. What is the ratio of the Rating (1=low 6=high) of Kyrgyz Republic in 2007 to that in 2014?
Offer a very short reply. 1. What is the ratio of the Rating (1=low 6=high) of Latin America(developing only) in 2008 to that in 2009?
Provide a succinct answer. 1.02. What is the ratio of the Rating (1=low 6=high) in Middle income in 2008 to that in 2009?
Offer a terse response. 0.98. What is the ratio of the Rating (1=low 6=high) of Sub-Saharan Africa (developing only) in 2008 to that in 2009?
Provide a short and direct response. 0.98. What is the ratio of the Rating (1=low 6=high) in Kyrgyz Republic in 2008 to that in 2009?
Provide a short and direct response. 1. What is the ratio of the Rating (1=low 6=high) in Middle income in 2008 to that in 2010?
Keep it short and to the point. 0.97. What is the ratio of the Rating (1=low 6=high) of Sub-Saharan Africa (developing only) in 2008 to that in 2010?
Your answer should be compact. 0.96. What is the ratio of the Rating (1=low 6=high) in Kyrgyz Republic in 2008 to that in 2010?
Offer a very short reply. 1. What is the ratio of the Rating (1=low 6=high) of Latin America(developing only) in 2008 to that in 2011?
Your answer should be compact. 1.02. What is the ratio of the Rating (1=low 6=high) in Middle income in 2008 to that in 2011?
Offer a terse response. 0.99. What is the ratio of the Rating (1=low 6=high) of Sub-Saharan Africa (developing only) in 2008 to that in 2011?
Your answer should be very brief. 0.95. What is the ratio of the Rating (1=low 6=high) in Kyrgyz Republic in 2008 to that in 2011?
Provide a short and direct response. 1. What is the ratio of the Rating (1=low 6=high) in Latin America(developing only) in 2008 to that in 2012?
Your response must be concise. 1.02. What is the ratio of the Rating (1=low 6=high) in Middle income in 2008 to that in 2012?
Your answer should be compact. 0.99. What is the ratio of the Rating (1=low 6=high) of Sub-Saharan Africa (developing only) in 2008 to that in 2012?
Provide a succinct answer. 0.96. What is the ratio of the Rating (1=low 6=high) in Latin America(developing only) in 2008 to that in 2013?
Offer a terse response. 1.02. What is the ratio of the Rating (1=low 6=high) in Middle income in 2008 to that in 2013?
Ensure brevity in your answer.  1. What is the ratio of the Rating (1=low 6=high) in Sub-Saharan Africa (developing only) in 2008 to that in 2013?
Provide a short and direct response. 0.96. What is the ratio of the Rating (1=low 6=high) in Kyrgyz Republic in 2008 to that in 2013?
Make the answer very short. 1. What is the ratio of the Rating (1=low 6=high) in Latin America(developing only) in 2008 to that in 2014?
Ensure brevity in your answer.  1.02. What is the ratio of the Rating (1=low 6=high) of Middle income in 2008 to that in 2014?
Ensure brevity in your answer.  1.01. What is the ratio of the Rating (1=low 6=high) of Sub-Saharan Africa (developing only) in 2008 to that in 2014?
Make the answer very short. 0.97. What is the ratio of the Rating (1=low 6=high) in Kyrgyz Republic in 2008 to that in 2014?
Provide a succinct answer. 1. What is the ratio of the Rating (1=low 6=high) of Latin America(developing only) in 2009 to that in 2010?
Keep it short and to the point. 0.98. What is the ratio of the Rating (1=low 6=high) in Middle income in 2009 to that in 2010?
Give a very brief answer. 0.99. What is the ratio of the Rating (1=low 6=high) in Sub-Saharan Africa (developing only) in 2009 to that in 2010?
Your response must be concise. 0.97. What is the ratio of the Rating (1=low 6=high) in Kyrgyz Republic in 2009 to that in 2010?
Offer a terse response. 1. What is the ratio of the Rating (1=low 6=high) in Latin America(developing only) in 2009 to that in 2011?
Make the answer very short. 1. What is the ratio of the Rating (1=low 6=high) in Sub-Saharan Africa (developing only) in 2009 to that in 2011?
Your answer should be compact. 0.96. What is the ratio of the Rating (1=low 6=high) of Sub-Saharan Africa (developing only) in 2009 to that in 2012?
Offer a terse response. 0.98. What is the ratio of the Rating (1=low 6=high) in Kyrgyz Republic in 2009 to that in 2012?
Offer a terse response. 1. What is the ratio of the Rating (1=low 6=high) of Latin America(developing only) in 2009 to that in 2013?
Keep it short and to the point. 1. What is the ratio of the Rating (1=low 6=high) in Middle income in 2009 to that in 2013?
Your answer should be very brief. 1.01. What is the ratio of the Rating (1=low 6=high) of Sub-Saharan Africa (developing only) in 2009 to that in 2013?
Keep it short and to the point. 0.98. What is the ratio of the Rating (1=low 6=high) of Kyrgyz Republic in 2009 to that in 2013?
Your answer should be compact. 1. What is the ratio of the Rating (1=low 6=high) of Latin America(developing only) in 2009 to that in 2014?
Provide a succinct answer. 1. What is the ratio of the Rating (1=low 6=high) of Middle income in 2009 to that in 2014?
Offer a terse response. 1.02. What is the ratio of the Rating (1=low 6=high) of Sub-Saharan Africa (developing only) in 2009 to that in 2014?
Your response must be concise. 0.98. What is the ratio of the Rating (1=low 6=high) of Kyrgyz Republic in 2009 to that in 2014?
Give a very brief answer. 1. What is the ratio of the Rating (1=low 6=high) in Latin America(developing only) in 2010 to that in 2011?
Keep it short and to the point. 1.02. What is the ratio of the Rating (1=low 6=high) in Middle income in 2010 to that in 2011?
Your answer should be compact. 1.02. What is the ratio of the Rating (1=low 6=high) of Latin America(developing only) in 2010 to that in 2012?
Offer a terse response. 1.02. What is the ratio of the Rating (1=low 6=high) of Middle income in 2010 to that in 2012?
Make the answer very short. 1.02. What is the ratio of the Rating (1=low 6=high) in Sub-Saharan Africa (developing only) in 2010 to that in 2012?
Your answer should be compact. 1.01. What is the ratio of the Rating (1=low 6=high) of Kyrgyz Republic in 2010 to that in 2012?
Provide a short and direct response. 1. What is the ratio of the Rating (1=low 6=high) of Latin America(developing only) in 2010 to that in 2013?
Your answer should be compact. 1.02. What is the ratio of the Rating (1=low 6=high) in Middle income in 2010 to that in 2013?
Offer a very short reply. 1.03. What is the ratio of the Rating (1=low 6=high) in Latin America(developing only) in 2010 to that in 2014?
Make the answer very short. 1.02. What is the ratio of the Rating (1=low 6=high) of Middle income in 2010 to that in 2014?
Give a very brief answer. 1.04. What is the ratio of the Rating (1=low 6=high) in Kyrgyz Republic in 2010 to that in 2014?
Offer a very short reply. 1. What is the ratio of the Rating (1=low 6=high) of Sub-Saharan Africa (developing only) in 2011 to that in 2012?
Give a very brief answer. 1.01. What is the ratio of the Rating (1=low 6=high) in Kyrgyz Republic in 2011 to that in 2012?
Provide a short and direct response. 1. What is the ratio of the Rating (1=low 6=high) in Middle income in 2011 to that in 2013?
Your response must be concise. 1.01. What is the ratio of the Rating (1=low 6=high) in Sub-Saharan Africa (developing only) in 2011 to that in 2013?
Keep it short and to the point. 1.01. What is the ratio of the Rating (1=low 6=high) of Kyrgyz Republic in 2011 to that in 2013?
Make the answer very short. 1. What is the ratio of the Rating (1=low 6=high) of Latin America(developing only) in 2011 to that in 2014?
Offer a very short reply. 1. What is the ratio of the Rating (1=low 6=high) in Sub-Saharan Africa (developing only) in 2011 to that in 2014?
Provide a short and direct response. 1.02. What is the ratio of the Rating (1=low 6=high) of Kyrgyz Republic in 2011 to that in 2014?
Your answer should be compact. 1. What is the ratio of the Rating (1=low 6=high) in Latin America(developing only) in 2012 to that in 2013?
Your response must be concise. 1. What is the ratio of the Rating (1=low 6=high) of Middle income in 2012 to that in 2013?
Offer a terse response. 1.01. What is the ratio of the Rating (1=low 6=high) of Middle income in 2012 to that in 2014?
Ensure brevity in your answer.  1.02. What is the ratio of the Rating (1=low 6=high) in Kyrgyz Republic in 2012 to that in 2014?
Your answer should be very brief. 1. What is the ratio of the Rating (1=low 6=high) in Latin America(developing only) in 2013 to that in 2014?
Ensure brevity in your answer.  1. What is the ratio of the Rating (1=low 6=high) of Middle income in 2013 to that in 2014?
Ensure brevity in your answer.  1.01. What is the ratio of the Rating (1=low 6=high) in Kyrgyz Republic in 2013 to that in 2014?
Provide a succinct answer. 1. What is the difference between the highest and the second highest Rating (1=low 6=high) in Middle income?
Provide a short and direct response. 0.05. What is the difference between the highest and the second highest Rating (1=low 6=high) of Sub-Saharan Africa (developing only)?
Provide a succinct answer. 0.03. What is the difference between the highest and the second highest Rating (1=low 6=high) in Kyrgyz Republic?
Your response must be concise. 0. What is the difference between the highest and the lowest Rating (1=low 6=high) of Latin America(developing only)?
Your answer should be compact. 0.06. What is the difference between the highest and the lowest Rating (1=low 6=high) in Middle income?
Your response must be concise. 0.13. What is the difference between the highest and the lowest Rating (1=low 6=high) of Sub-Saharan Africa (developing only)?
Make the answer very short. 0.17. What is the difference between the highest and the lowest Rating (1=low 6=high) of Kyrgyz Republic?
Give a very brief answer. 0. 